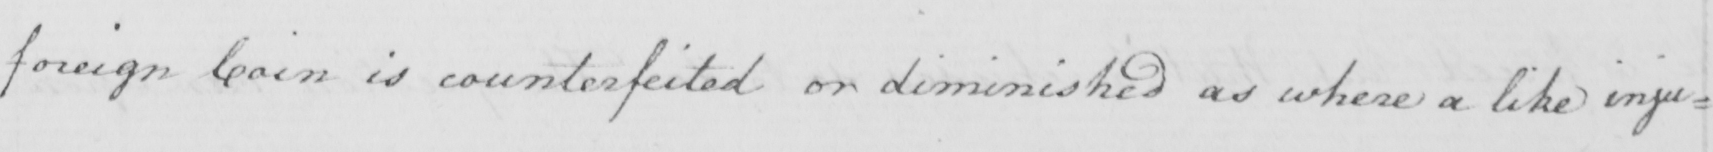What does this handwritten line say? foreign Coin is counterfeited or diminished as where a like inju= 